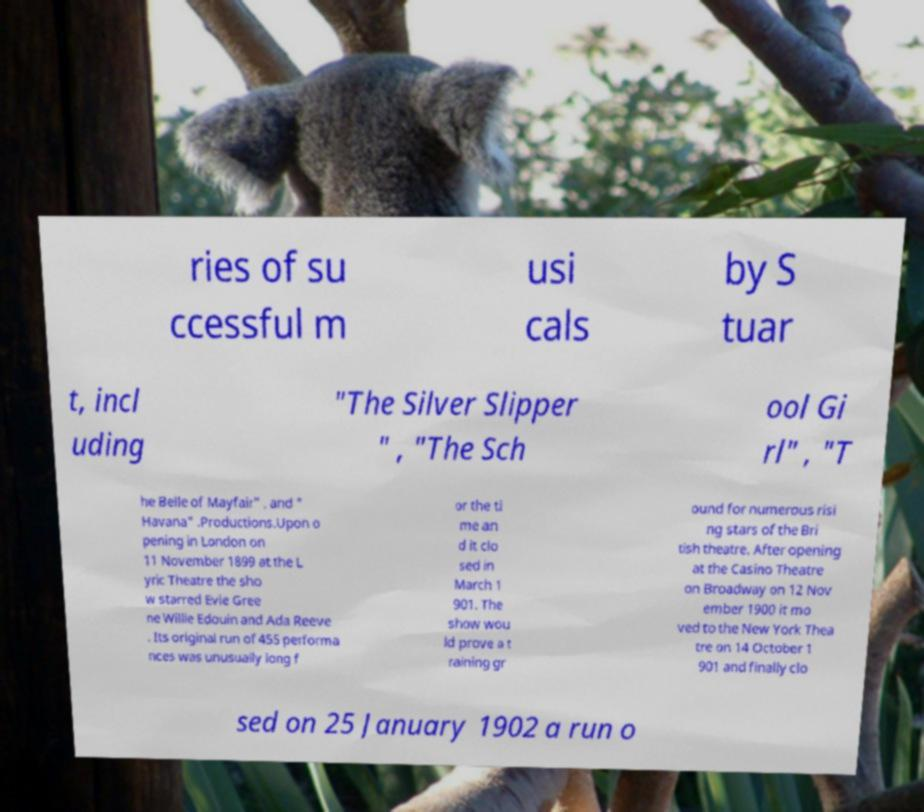Please identify and transcribe the text found in this image. ries of su ccessful m usi cals by S tuar t, incl uding "The Silver Slipper " , "The Sch ool Gi rl" , "T he Belle of Mayfair" , and " Havana" .Productions.Upon o pening in London on 11 November 1899 at the L yric Theatre the sho w starred Evie Gree ne Willie Edouin and Ada Reeve . Its original run of 455 performa nces was unusually long f or the ti me an d it clo sed in March 1 901. The show wou ld prove a t raining gr ound for numerous risi ng stars of the Bri tish theatre. After opening at the Casino Theatre on Broadway on 12 Nov ember 1900 it mo ved to the New York Thea tre on 14 October 1 901 and finally clo sed on 25 January 1902 a run o 